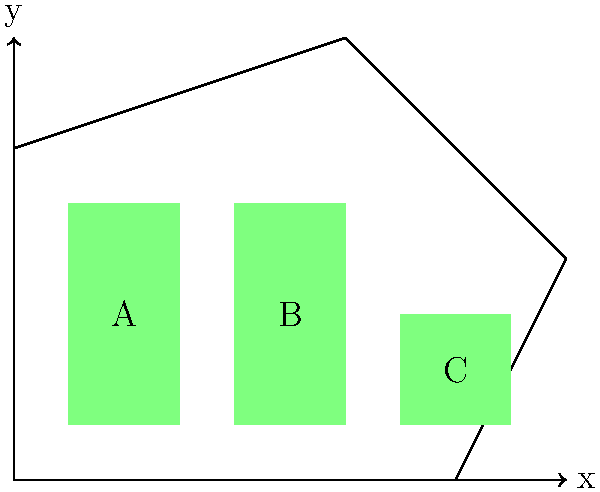An agricultural company wants to maximize the use of rectangular plots within an irregular-shaped field. The field's boundary is defined by the coordinates (0,0), (80,0), (100,40), (60,80), and (0,60) in a Cartesian plane where each unit represents 10 meters. Three rectangular plots A, B, and C have been placed as shown in the diagram. What is the total area of unused space in the field, in square meters? To solve this problem, we'll follow these steps:

1) Calculate the total area of the irregular field:
   We can divide the field into a triangle and a trapezoid.
   Triangle area: $\frac{1}{2} \times 20 \times 40 = 400$ sq units
   Trapezoid area: $\frac{1}{2}(80 + 60) \times 60 = 4200$ sq units
   Total field area: $400 + 4200 = 4600$ sq units

2) Calculate the areas of the rectangular plots:
   Plot A: $20 \times 40 = 800$ sq units
   Plot B: $20 \times 40 = 800$ sq units
   Plot C: $20 \times 20 = 400$ sq units
   Total plot area: $800 + 800 + 400 = 2000$ sq units

3) Calculate the unused area:
   Unused area = Total field area - Total plot area
   $4600 - 2000 = 2600$ sq units

4) Convert to square meters:
   Each unit represents 10 meters, so each square unit is 100 sq meters.
   Unused area in sq meters: $2600 \times 100 = 260,000$ sq meters

Therefore, the total area of unused space in the field is 260,000 square meters.
Answer: 260,000 square meters 